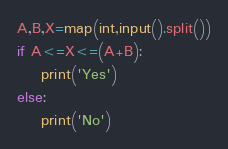Convert code to text. <code><loc_0><loc_0><loc_500><loc_500><_Python_>A,B,X=map(int,input().split())
if A<=X<=(A+B):
    print('Yes')
else:
    print('No')</code> 